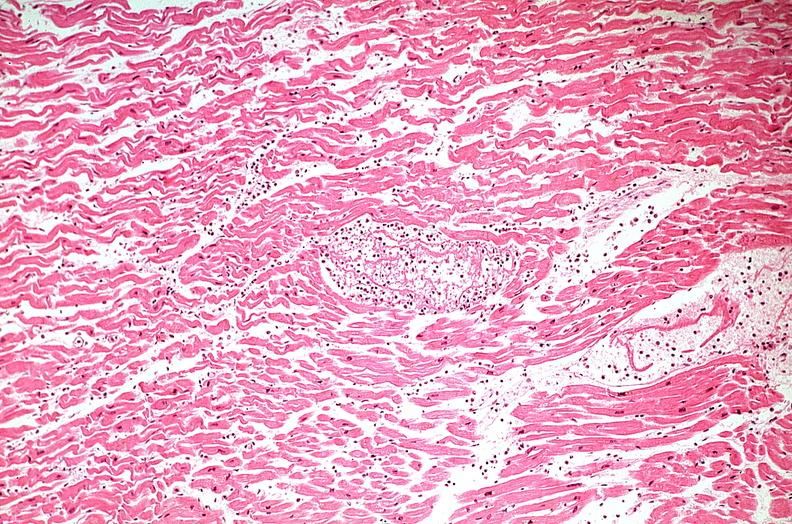s cardiovascular present?
Answer the question using a single word or phrase. Yes 